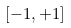Convert formula to latex. <formula><loc_0><loc_0><loc_500><loc_500>[ - 1 , + 1 ]</formula> 